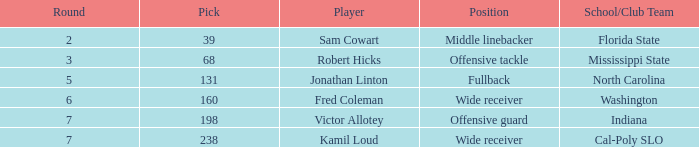Which player has a round less than 5 and a school/club team from florida state? Sam Cowart. 